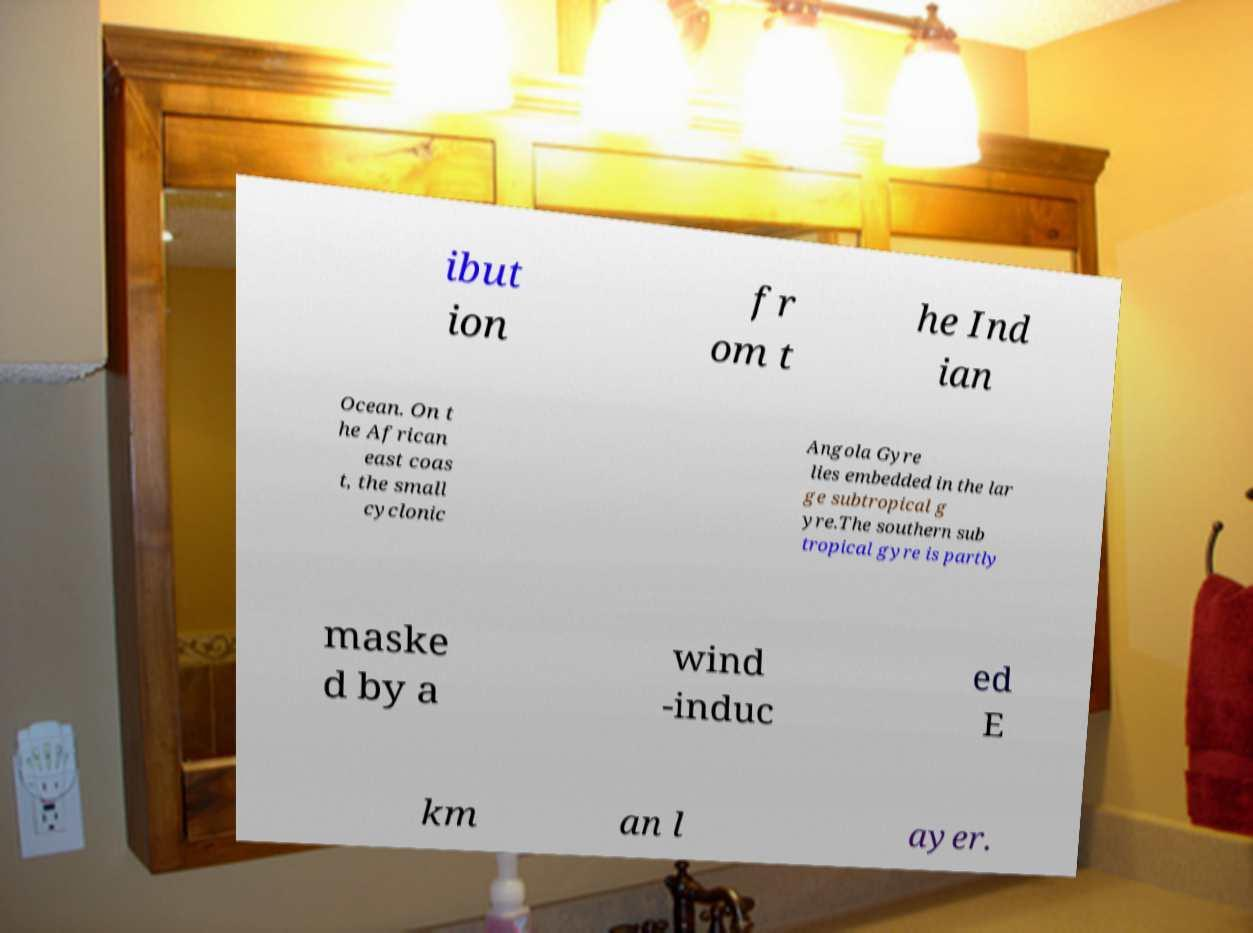I need the written content from this picture converted into text. Can you do that? ibut ion fr om t he Ind ian Ocean. On t he African east coas t, the small cyclonic Angola Gyre lies embedded in the lar ge subtropical g yre.The southern sub tropical gyre is partly maske d by a wind -induc ed E km an l ayer. 